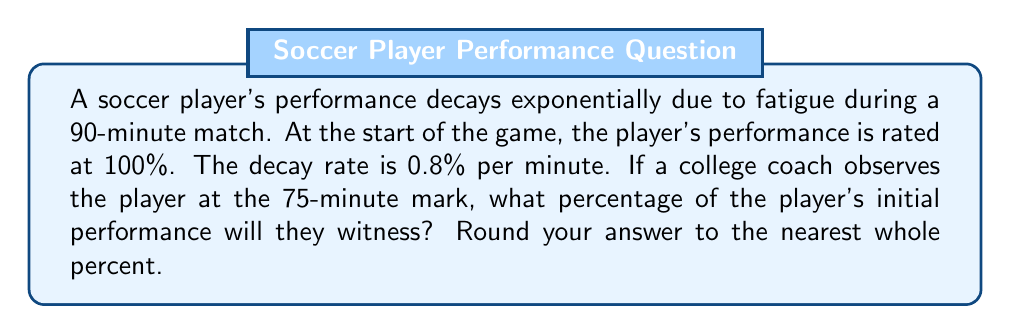Solve this math problem. Let's approach this step-by-step:

1) The exponential decay formula is:
   $$A(t) = A_0 \cdot (1-r)^t$$
   where:
   $A(t)$ is the amount at time $t$
   $A_0$ is the initial amount
   $r$ is the decay rate per unit of time
   $t$ is the time elapsed

2) In this case:
   $A_0 = 100\%$ (initial performance)
   $r = 0.008$ (0.8% written as a decimal)
   $t = 75$ minutes

3) Plugging these values into the formula:
   $$A(75) = 100 \cdot (1-0.008)^{75}$$

4) Simplify inside the parentheses:
   $$A(75) = 100 \cdot (0.992)^{75}$$

5) Use a calculator to evaluate $(0.992)^{75}$:
   $$A(75) = 100 \cdot 0.5456$$

6) Multiply:
   $$A(75) = 54.56\%$$

7) Rounding to the nearest whole percent:
   $$A(75) \approx 55\%$$

Therefore, at the 75-minute mark, the player will be performing at approximately 55% of their initial performance level.
Answer: 55% 